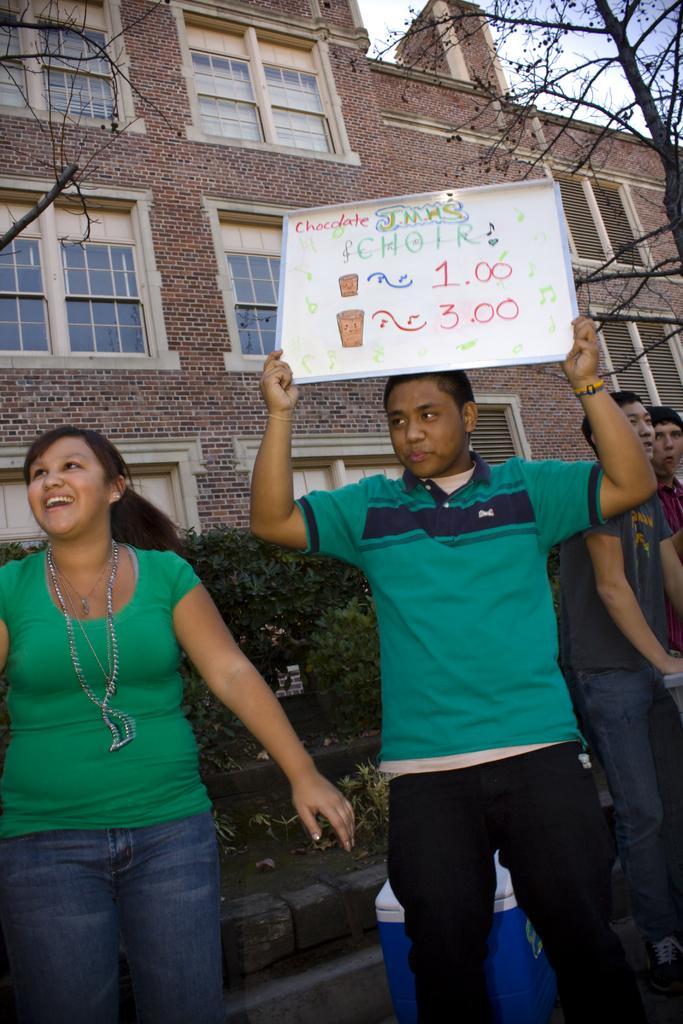Please provide a concise description of this image. The woman on the left side of the picture wearing a green T-shirt is smiling. Beside her, the man in green T-shirt is holding a white board in his hands. We see some text written on the whiteboard. Beside him, we see two people standing. There are trees and a building in the background. 